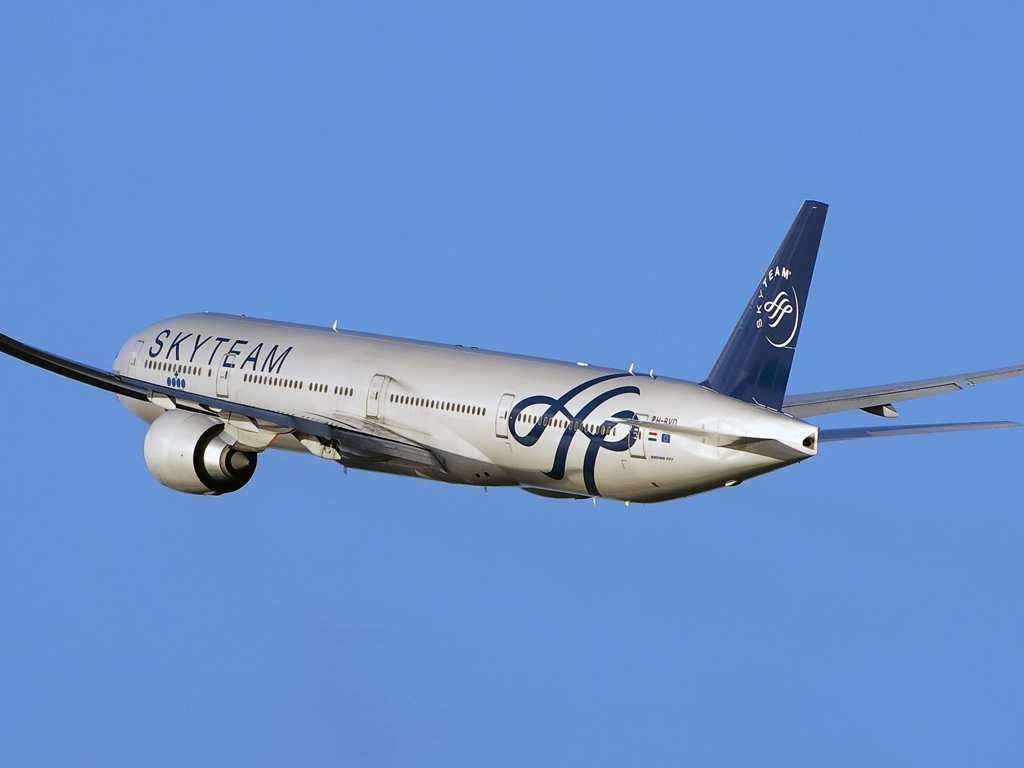What can you tell me about the model of the aircraft in the image? The aircraft in the image is a modern passenger jet, typically characterized by its sleek design, twin engines mounted under the wings, and advanced aerodynamics. The distinctive wingtips with upward-curved extensions, known as winglets, suggest it's designed for long-haul flights with fuel efficiency in mind. 